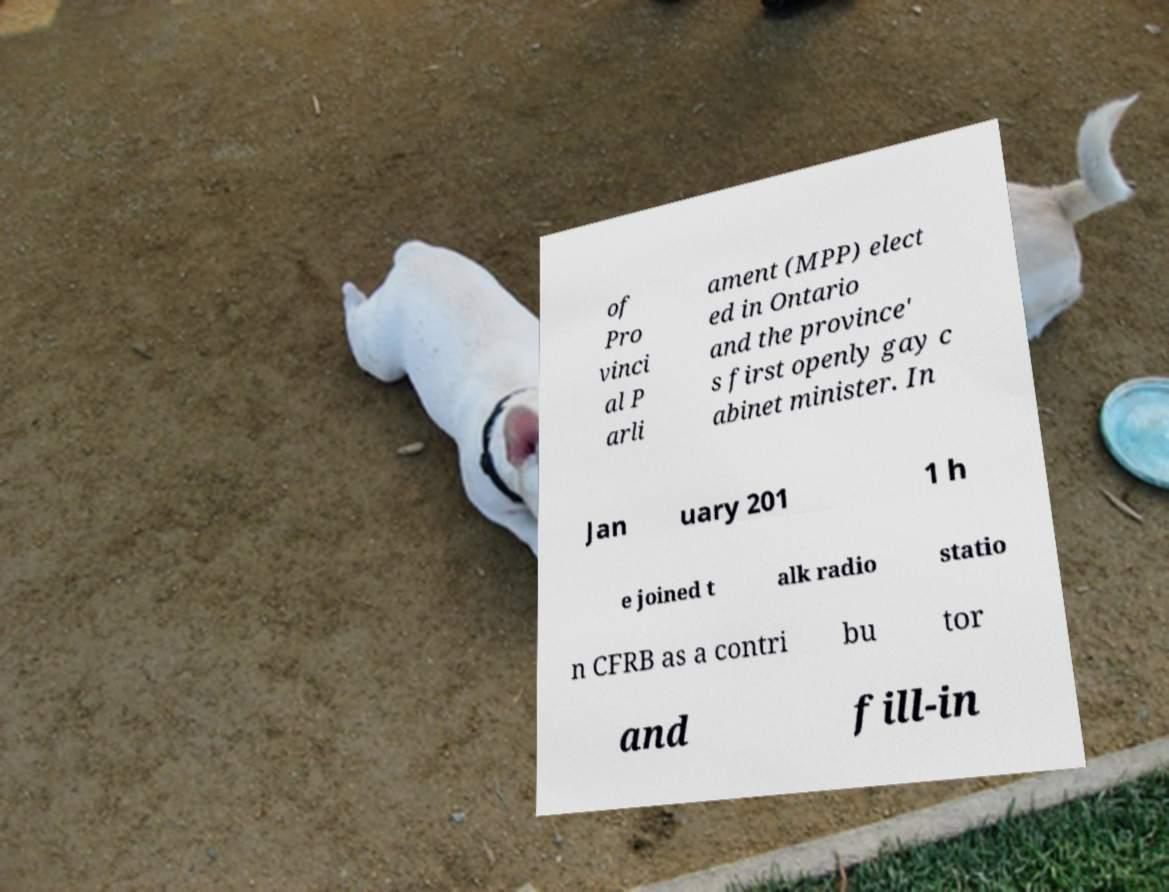Could you assist in decoding the text presented in this image and type it out clearly? of Pro vinci al P arli ament (MPP) elect ed in Ontario and the province' s first openly gay c abinet minister. In Jan uary 201 1 h e joined t alk radio statio n CFRB as a contri bu tor and fill-in 